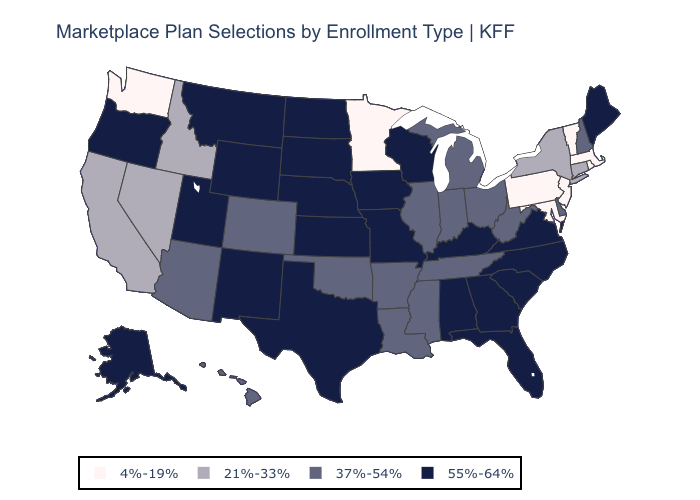Does Colorado have a lower value than Vermont?
Answer briefly. No. What is the value of Maine?
Short answer required. 55%-64%. Does Vermont have a higher value than Montana?
Quick response, please. No. Among the states that border Georgia , does Florida have the lowest value?
Give a very brief answer. No. What is the value of Maryland?
Quick response, please. 4%-19%. What is the highest value in the USA?
Quick response, please. 55%-64%. What is the value of Idaho?
Write a very short answer. 21%-33%. What is the highest value in states that border Nevada?
Keep it brief. 55%-64%. How many symbols are there in the legend?
Short answer required. 4. Name the states that have a value in the range 21%-33%?
Write a very short answer. California, Connecticut, Idaho, Nevada, New York. Does New York have a higher value than Tennessee?
Write a very short answer. No. Which states have the lowest value in the MidWest?
Write a very short answer. Minnesota. What is the lowest value in states that border New Jersey?
Short answer required. 4%-19%. Which states hav the highest value in the West?
Answer briefly. Alaska, Montana, New Mexico, Oregon, Utah, Wyoming. Which states have the highest value in the USA?
Give a very brief answer. Alabama, Alaska, Florida, Georgia, Iowa, Kansas, Kentucky, Maine, Missouri, Montana, Nebraska, New Mexico, North Carolina, North Dakota, Oregon, South Carolina, South Dakota, Texas, Utah, Virginia, Wisconsin, Wyoming. 